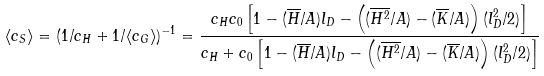Convert formula to latex. <formula><loc_0><loc_0><loc_500><loc_500>\langle c _ { S } \rangle = ( 1 / c _ { H } + 1 / \langle c _ { G } \rangle ) ^ { - 1 } = \frac { c _ { H } c _ { 0 } \left [ 1 - ( \overline { H } / A ) l _ { D } - \left ( ( \overline { H ^ { 2 } } / A ) - ( \overline { K } / A ) \right ) ( l _ { D } ^ { 2 } / { 2 } ) \right ] } { c _ { H } + c _ { 0 } \left [ 1 - ( \overline { H } / A ) l _ { D } - \left ( ( \overline { H ^ { 2 } } / A ) - ( \overline { K } / A ) \right ) ( l _ { D } ^ { 2 } / { 2 } ) \right ] }</formula> 